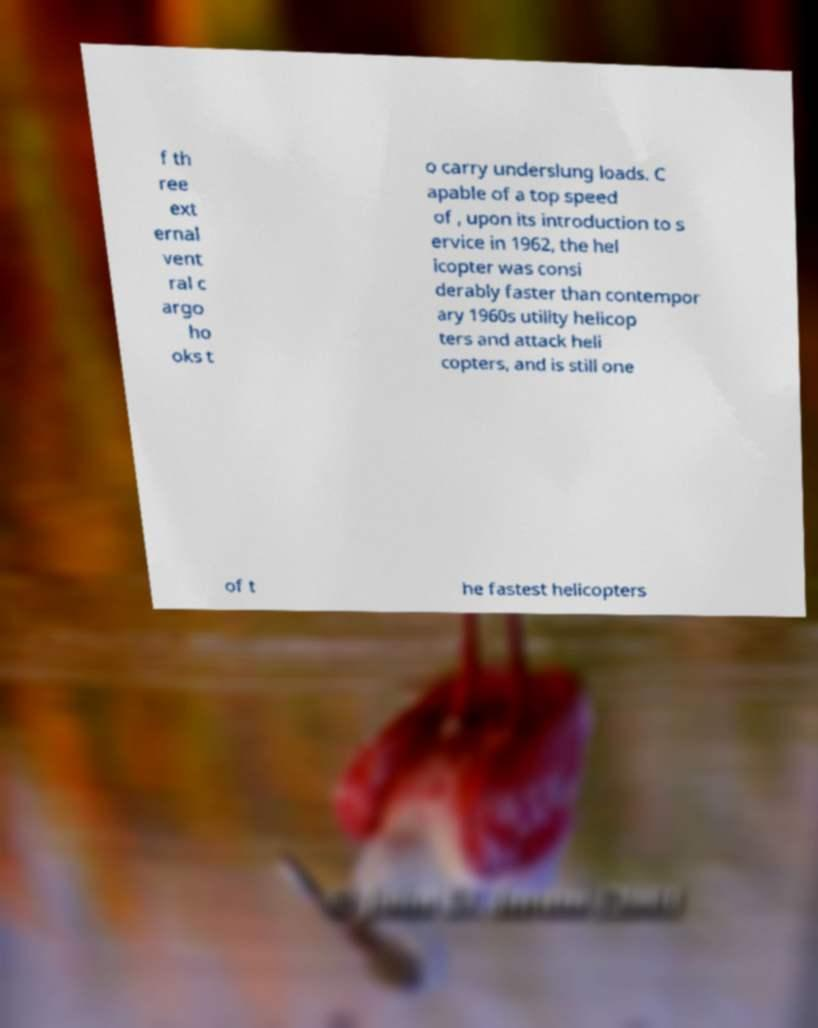Could you assist in decoding the text presented in this image and type it out clearly? f th ree ext ernal vent ral c argo ho oks t o carry underslung loads. C apable of a top speed of , upon its introduction to s ervice in 1962, the hel icopter was consi derably faster than contempor ary 1960s utility helicop ters and attack heli copters, and is still one of t he fastest helicopters 